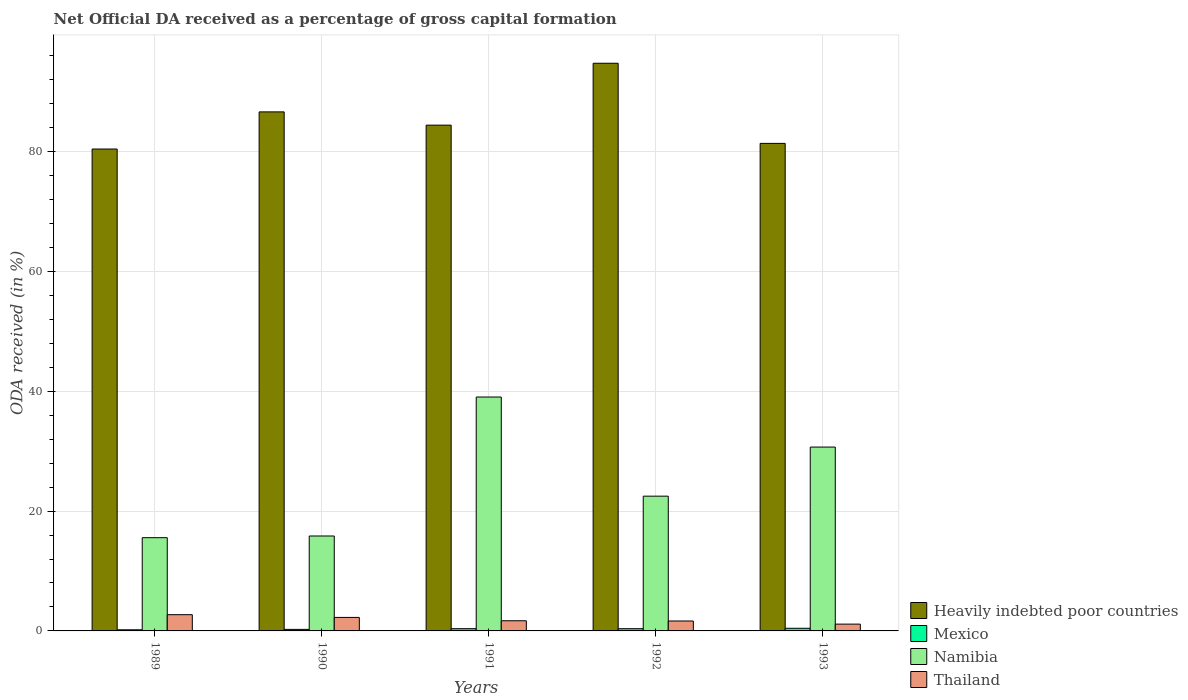How many different coloured bars are there?
Give a very brief answer. 4. How many groups of bars are there?
Provide a short and direct response. 5. Are the number of bars per tick equal to the number of legend labels?
Your answer should be very brief. Yes. Are the number of bars on each tick of the X-axis equal?
Provide a short and direct response. Yes. In how many cases, is the number of bars for a given year not equal to the number of legend labels?
Keep it short and to the point. 0. What is the net ODA received in Heavily indebted poor countries in 1990?
Offer a very short reply. 86.64. Across all years, what is the maximum net ODA received in Heavily indebted poor countries?
Provide a short and direct response. 94.76. Across all years, what is the minimum net ODA received in Mexico?
Provide a short and direct response. 0.19. In which year was the net ODA received in Heavily indebted poor countries maximum?
Keep it short and to the point. 1992. What is the total net ODA received in Namibia in the graph?
Give a very brief answer. 123.64. What is the difference between the net ODA received in Namibia in 1989 and that in 1993?
Make the answer very short. -15.12. What is the difference between the net ODA received in Namibia in 1989 and the net ODA received in Mexico in 1990?
Give a very brief answer. 15.31. What is the average net ODA received in Heavily indebted poor countries per year?
Your response must be concise. 85.53. In the year 1993, what is the difference between the net ODA received in Thailand and net ODA received in Mexico?
Offer a terse response. 0.69. What is the ratio of the net ODA received in Namibia in 1990 to that in 1993?
Offer a terse response. 0.52. Is the net ODA received in Mexico in 1990 less than that in 1992?
Make the answer very short. Yes. What is the difference between the highest and the second highest net ODA received in Thailand?
Keep it short and to the point. 0.46. What is the difference between the highest and the lowest net ODA received in Namibia?
Keep it short and to the point. 23.48. In how many years, is the net ODA received in Mexico greater than the average net ODA received in Mexico taken over all years?
Provide a short and direct response. 3. Is it the case that in every year, the sum of the net ODA received in Namibia and net ODA received in Mexico is greater than the sum of net ODA received in Heavily indebted poor countries and net ODA received in Thailand?
Keep it short and to the point. Yes. What does the 2nd bar from the left in 1990 represents?
Your response must be concise. Mexico. What does the 2nd bar from the right in 1991 represents?
Give a very brief answer. Namibia. Is it the case that in every year, the sum of the net ODA received in Heavily indebted poor countries and net ODA received in Namibia is greater than the net ODA received in Mexico?
Your response must be concise. Yes. How many years are there in the graph?
Your response must be concise. 5. How many legend labels are there?
Offer a very short reply. 4. How are the legend labels stacked?
Your answer should be compact. Vertical. What is the title of the graph?
Your answer should be compact. Net Official DA received as a percentage of gross capital formation. What is the label or title of the Y-axis?
Your response must be concise. ODA received (in %). What is the ODA received (in %) in Heavily indebted poor countries in 1989?
Offer a very short reply. 80.44. What is the ODA received (in %) in Mexico in 1989?
Your response must be concise. 0.19. What is the ODA received (in %) of Namibia in 1989?
Make the answer very short. 15.57. What is the ODA received (in %) in Thailand in 1989?
Your answer should be compact. 2.71. What is the ODA received (in %) of Heavily indebted poor countries in 1990?
Your answer should be very brief. 86.64. What is the ODA received (in %) in Mexico in 1990?
Your response must be concise. 0.26. What is the ODA received (in %) of Namibia in 1990?
Offer a very short reply. 15.85. What is the ODA received (in %) in Thailand in 1990?
Your answer should be compact. 2.25. What is the ODA received (in %) of Heavily indebted poor countries in 1991?
Provide a short and direct response. 84.43. What is the ODA received (in %) of Mexico in 1991?
Your response must be concise. 0.37. What is the ODA received (in %) of Namibia in 1991?
Offer a very short reply. 39.04. What is the ODA received (in %) in Thailand in 1991?
Provide a succinct answer. 1.7. What is the ODA received (in %) of Heavily indebted poor countries in 1992?
Your response must be concise. 94.76. What is the ODA received (in %) in Mexico in 1992?
Give a very brief answer. 0.37. What is the ODA received (in %) in Namibia in 1992?
Make the answer very short. 22.49. What is the ODA received (in %) in Thailand in 1992?
Your response must be concise. 1.66. What is the ODA received (in %) of Heavily indebted poor countries in 1993?
Give a very brief answer. 81.38. What is the ODA received (in %) in Mexico in 1993?
Your answer should be compact. 0.44. What is the ODA received (in %) of Namibia in 1993?
Ensure brevity in your answer.  30.69. What is the ODA received (in %) in Thailand in 1993?
Provide a succinct answer. 1.14. Across all years, what is the maximum ODA received (in %) in Heavily indebted poor countries?
Offer a terse response. 94.76. Across all years, what is the maximum ODA received (in %) of Mexico?
Your response must be concise. 0.44. Across all years, what is the maximum ODA received (in %) of Namibia?
Your answer should be very brief. 39.04. Across all years, what is the maximum ODA received (in %) in Thailand?
Provide a succinct answer. 2.71. Across all years, what is the minimum ODA received (in %) of Heavily indebted poor countries?
Offer a very short reply. 80.44. Across all years, what is the minimum ODA received (in %) in Mexico?
Provide a short and direct response. 0.19. Across all years, what is the minimum ODA received (in %) of Namibia?
Ensure brevity in your answer.  15.57. Across all years, what is the minimum ODA received (in %) in Thailand?
Your answer should be compact. 1.14. What is the total ODA received (in %) of Heavily indebted poor countries in the graph?
Your response must be concise. 427.64. What is the total ODA received (in %) in Mexico in the graph?
Offer a terse response. 1.63. What is the total ODA received (in %) of Namibia in the graph?
Provide a succinct answer. 123.64. What is the total ODA received (in %) in Thailand in the graph?
Your answer should be very brief. 9.45. What is the difference between the ODA received (in %) in Heavily indebted poor countries in 1989 and that in 1990?
Keep it short and to the point. -6.2. What is the difference between the ODA received (in %) of Mexico in 1989 and that in 1990?
Make the answer very short. -0.07. What is the difference between the ODA received (in %) of Namibia in 1989 and that in 1990?
Keep it short and to the point. -0.28. What is the difference between the ODA received (in %) in Thailand in 1989 and that in 1990?
Make the answer very short. 0.46. What is the difference between the ODA received (in %) of Heavily indebted poor countries in 1989 and that in 1991?
Your answer should be compact. -3.99. What is the difference between the ODA received (in %) in Mexico in 1989 and that in 1991?
Provide a short and direct response. -0.18. What is the difference between the ODA received (in %) in Namibia in 1989 and that in 1991?
Provide a short and direct response. -23.48. What is the difference between the ODA received (in %) in Thailand in 1989 and that in 1991?
Your answer should be compact. 1.01. What is the difference between the ODA received (in %) of Heavily indebted poor countries in 1989 and that in 1992?
Give a very brief answer. -14.32. What is the difference between the ODA received (in %) in Mexico in 1989 and that in 1992?
Offer a very short reply. -0.18. What is the difference between the ODA received (in %) of Namibia in 1989 and that in 1992?
Give a very brief answer. -6.93. What is the difference between the ODA received (in %) of Thailand in 1989 and that in 1992?
Ensure brevity in your answer.  1.05. What is the difference between the ODA received (in %) in Heavily indebted poor countries in 1989 and that in 1993?
Provide a short and direct response. -0.94. What is the difference between the ODA received (in %) in Mexico in 1989 and that in 1993?
Your response must be concise. -0.25. What is the difference between the ODA received (in %) of Namibia in 1989 and that in 1993?
Keep it short and to the point. -15.12. What is the difference between the ODA received (in %) of Thailand in 1989 and that in 1993?
Make the answer very short. 1.57. What is the difference between the ODA received (in %) of Heavily indebted poor countries in 1990 and that in 1991?
Your response must be concise. 2.21. What is the difference between the ODA received (in %) in Mexico in 1990 and that in 1991?
Give a very brief answer. -0.12. What is the difference between the ODA received (in %) in Namibia in 1990 and that in 1991?
Make the answer very short. -23.2. What is the difference between the ODA received (in %) in Thailand in 1990 and that in 1991?
Provide a short and direct response. 0.56. What is the difference between the ODA received (in %) of Heavily indebted poor countries in 1990 and that in 1992?
Ensure brevity in your answer.  -8.12. What is the difference between the ODA received (in %) of Mexico in 1990 and that in 1992?
Offer a terse response. -0.11. What is the difference between the ODA received (in %) of Namibia in 1990 and that in 1992?
Provide a succinct answer. -6.65. What is the difference between the ODA received (in %) of Thailand in 1990 and that in 1992?
Offer a terse response. 0.6. What is the difference between the ODA received (in %) of Heavily indebted poor countries in 1990 and that in 1993?
Your answer should be compact. 5.26. What is the difference between the ODA received (in %) in Mexico in 1990 and that in 1993?
Offer a terse response. -0.19. What is the difference between the ODA received (in %) in Namibia in 1990 and that in 1993?
Ensure brevity in your answer.  -14.84. What is the difference between the ODA received (in %) in Thailand in 1990 and that in 1993?
Provide a short and direct response. 1.12. What is the difference between the ODA received (in %) in Heavily indebted poor countries in 1991 and that in 1992?
Your answer should be very brief. -10.33. What is the difference between the ODA received (in %) in Mexico in 1991 and that in 1992?
Your answer should be very brief. 0. What is the difference between the ODA received (in %) of Namibia in 1991 and that in 1992?
Offer a very short reply. 16.55. What is the difference between the ODA received (in %) of Thailand in 1991 and that in 1992?
Ensure brevity in your answer.  0.04. What is the difference between the ODA received (in %) of Heavily indebted poor countries in 1991 and that in 1993?
Provide a short and direct response. 3.05. What is the difference between the ODA received (in %) of Mexico in 1991 and that in 1993?
Your answer should be compact. -0.07. What is the difference between the ODA received (in %) in Namibia in 1991 and that in 1993?
Make the answer very short. 8.35. What is the difference between the ODA received (in %) of Thailand in 1991 and that in 1993?
Provide a succinct answer. 0.56. What is the difference between the ODA received (in %) in Heavily indebted poor countries in 1992 and that in 1993?
Offer a terse response. 13.38. What is the difference between the ODA received (in %) of Mexico in 1992 and that in 1993?
Make the answer very short. -0.07. What is the difference between the ODA received (in %) in Namibia in 1992 and that in 1993?
Your answer should be compact. -8.2. What is the difference between the ODA received (in %) in Thailand in 1992 and that in 1993?
Provide a short and direct response. 0.52. What is the difference between the ODA received (in %) in Heavily indebted poor countries in 1989 and the ODA received (in %) in Mexico in 1990?
Your answer should be very brief. 80.18. What is the difference between the ODA received (in %) of Heavily indebted poor countries in 1989 and the ODA received (in %) of Namibia in 1990?
Your answer should be compact. 64.59. What is the difference between the ODA received (in %) in Heavily indebted poor countries in 1989 and the ODA received (in %) in Thailand in 1990?
Your response must be concise. 78.19. What is the difference between the ODA received (in %) of Mexico in 1989 and the ODA received (in %) of Namibia in 1990?
Your answer should be very brief. -15.66. What is the difference between the ODA received (in %) of Mexico in 1989 and the ODA received (in %) of Thailand in 1990?
Provide a short and direct response. -2.07. What is the difference between the ODA received (in %) in Namibia in 1989 and the ODA received (in %) in Thailand in 1990?
Your response must be concise. 13.31. What is the difference between the ODA received (in %) of Heavily indebted poor countries in 1989 and the ODA received (in %) of Mexico in 1991?
Your answer should be compact. 80.07. What is the difference between the ODA received (in %) of Heavily indebted poor countries in 1989 and the ODA received (in %) of Namibia in 1991?
Your answer should be compact. 41.4. What is the difference between the ODA received (in %) in Heavily indebted poor countries in 1989 and the ODA received (in %) in Thailand in 1991?
Give a very brief answer. 78.74. What is the difference between the ODA received (in %) in Mexico in 1989 and the ODA received (in %) in Namibia in 1991?
Ensure brevity in your answer.  -38.86. What is the difference between the ODA received (in %) of Mexico in 1989 and the ODA received (in %) of Thailand in 1991?
Provide a short and direct response. -1.51. What is the difference between the ODA received (in %) of Namibia in 1989 and the ODA received (in %) of Thailand in 1991?
Offer a very short reply. 13.87. What is the difference between the ODA received (in %) of Heavily indebted poor countries in 1989 and the ODA received (in %) of Mexico in 1992?
Offer a terse response. 80.07. What is the difference between the ODA received (in %) in Heavily indebted poor countries in 1989 and the ODA received (in %) in Namibia in 1992?
Offer a terse response. 57.95. What is the difference between the ODA received (in %) in Heavily indebted poor countries in 1989 and the ODA received (in %) in Thailand in 1992?
Make the answer very short. 78.78. What is the difference between the ODA received (in %) of Mexico in 1989 and the ODA received (in %) of Namibia in 1992?
Make the answer very short. -22.31. What is the difference between the ODA received (in %) in Mexico in 1989 and the ODA received (in %) in Thailand in 1992?
Your answer should be compact. -1.47. What is the difference between the ODA received (in %) in Namibia in 1989 and the ODA received (in %) in Thailand in 1992?
Make the answer very short. 13.91. What is the difference between the ODA received (in %) of Heavily indebted poor countries in 1989 and the ODA received (in %) of Mexico in 1993?
Make the answer very short. 80. What is the difference between the ODA received (in %) of Heavily indebted poor countries in 1989 and the ODA received (in %) of Namibia in 1993?
Provide a short and direct response. 49.75. What is the difference between the ODA received (in %) in Heavily indebted poor countries in 1989 and the ODA received (in %) in Thailand in 1993?
Give a very brief answer. 79.3. What is the difference between the ODA received (in %) in Mexico in 1989 and the ODA received (in %) in Namibia in 1993?
Your response must be concise. -30.5. What is the difference between the ODA received (in %) in Mexico in 1989 and the ODA received (in %) in Thailand in 1993?
Provide a short and direct response. -0.95. What is the difference between the ODA received (in %) of Namibia in 1989 and the ODA received (in %) of Thailand in 1993?
Provide a succinct answer. 14.43. What is the difference between the ODA received (in %) of Heavily indebted poor countries in 1990 and the ODA received (in %) of Mexico in 1991?
Your answer should be very brief. 86.27. What is the difference between the ODA received (in %) in Heavily indebted poor countries in 1990 and the ODA received (in %) in Namibia in 1991?
Offer a terse response. 47.59. What is the difference between the ODA received (in %) of Heavily indebted poor countries in 1990 and the ODA received (in %) of Thailand in 1991?
Make the answer very short. 84.94. What is the difference between the ODA received (in %) in Mexico in 1990 and the ODA received (in %) in Namibia in 1991?
Ensure brevity in your answer.  -38.79. What is the difference between the ODA received (in %) in Mexico in 1990 and the ODA received (in %) in Thailand in 1991?
Your answer should be very brief. -1.44. What is the difference between the ODA received (in %) of Namibia in 1990 and the ODA received (in %) of Thailand in 1991?
Provide a short and direct response. 14.15. What is the difference between the ODA received (in %) of Heavily indebted poor countries in 1990 and the ODA received (in %) of Mexico in 1992?
Offer a very short reply. 86.27. What is the difference between the ODA received (in %) in Heavily indebted poor countries in 1990 and the ODA received (in %) in Namibia in 1992?
Your response must be concise. 64.14. What is the difference between the ODA received (in %) of Heavily indebted poor countries in 1990 and the ODA received (in %) of Thailand in 1992?
Provide a short and direct response. 84.98. What is the difference between the ODA received (in %) of Mexico in 1990 and the ODA received (in %) of Namibia in 1992?
Offer a terse response. -22.24. What is the difference between the ODA received (in %) in Mexico in 1990 and the ODA received (in %) in Thailand in 1992?
Your answer should be very brief. -1.4. What is the difference between the ODA received (in %) of Namibia in 1990 and the ODA received (in %) of Thailand in 1992?
Your response must be concise. 14.19. What is the difference between the ODA received (in %) in Heavily indebted poor countries in 1990 and the ODA received (in %) in Mexico in 1993?
Your answer should be very brief. 86.2. What is the difference between the ODA received (in %) of Heavily indebted poor countries in 1990 and the ODA received (in %) of Namibia in 1993?
Give a very brief answer. 55.95. What is the difference between the ODA received (in %) of Heavily indebted poor countries in 1990 and the ODA received (in %) of Thailand in 1993?
Provide a short and direct response. 85.5. What is the difference between the ODA received (in %) of Mexico in 1990 and the ODA received (in %) of Namibia in 1993?
Offer a terse response. -30.43. What is the difference between the ODA received (in %) of Mexico in 1990 and the ODA received (in %) of Thailand in 1993?
Make the answer very short. -0.88. What is the difference between the ODA received (in %) of Namibia in 1990 and the ODA received (in %) of Thailand in 1993?
Offer a terse response. 14.71. What is the difference between the ODA received (in %) in Heavily indebted poor countries in 1991 and the ODA received (in %) in Mexico in 1992?
Offer a terse response. 84.06. What is the difference between the ODA received (in %) in Heavily indebted poor countries in 1991 and the ODA received (in %) in Namibia in 1992?
Provide a short and direct response. 61.93. What is the difference between the ODA received (in %) in Heavily indebted poor countries in 1991 and the ODA received (in %) in Thailand in 1992?
Offer a terse response. 82.77. What is the difference between the ODA received (in %) in Mexico in 1991 and the ODA received (in %) in Namibia in 1992?
Provide a short and direct response. -22.12. What is the difference between the ODA received (in %) of Mexico in 1991 and the ODA received (in %) of Thailand in 1992?
Make the answer very short. -1.28. What is the difference between the ODA received (in %) in Namibia in 1991 and the ODA received (in %) in Thailand in 1992?
Provide a short and direct response. 37.39. What is the difference between the ODA received (in %) in Heavily indebted poor countries in 1991 and the ODA received (in %) in Mexico in 1993?
Make the answer very short. 83.98. What is the difference between the ODA received (in %) of Heavily indebted poor countries in 1991 and the ODA received (in %) of Namibia in 1993?
Provide a succinct answer. 53.74. What is the difference between the ODA received (in %) in Heavily indebted poor countries in 1991 and the ODA received (in %) in Thailand in 1993?
Offer a terse response. 83.29. What is the difference between the ODA received (in %) of Mexico in 1991 and the ODA received (in %) of Namibia in 1993?
Provide a short and direct response. -30.32. What is the difference between the ODA received (in %) of Mexico in 1991 and the ODA received (in %) of Thailand in 1993?
Your answer should be compact. -0.76. What is the difference between the ODA received (in %) in Namibia in 1991 and the ODA received (in %) in Thailand in 1993?
Provide a short and direct response. 37.91. What is the difference between the ODA received (in %) in Heavily indebted poor countries in 1992 and the ODA received (in %) in Mexico in 1993?
Offer a terse response. 94.31. What is the difference between the ODA received (in %) of Heavily indebted poor countries in 1992 and the ODA received (in %) of Namibia in 1993?
Your answer should be very brief. 64.07. What is the difference between the ODA received (in %) of Heavily indebted poor countries in 1992 and the ODA received (in %) of Thailand in 1993?
Offer a very short reply. 93.62. What is the difference between the ODA received (in %) of Mexico in 1992 and the ODA received (in %) of Namibia in 1993?
Your answer should be very brief. -30.32. What is the difference between the ODA received (in %) of Mexico in 1992 and the ODA received (in %) of Thailand in 1993?
Offer a terse response. -0.77. What is the difference between the ODA received (in %) of Namibia in 1992 and the ODA received (in %) of Thailand in 1993?
Offer a very short reply. 21.36. What is the average ODA received (in %) of Heavily indebted poor countries per year?
Give a very brief answer. 85.53. What is the average ODA received (in %) of Mexico per year?
Provide a succinct answer. 0.33. What is the average ODA received (in %) in Namibia per year?
Make the answer very short. 24.73. What is the average ODA received (in %) in Thailand per year?
Offer a terse response. 1.89. In the year 1989, what is the difference between the ODA received (in %) in Heavily indebted poor countries and ODA received (in %) in Mexico?
Give a very brief answer. 80.25. In the year 1989, what is the difference between the ODA received (in %) of Heavily indebted poor countries and ODA received (in %) of Namibia?
Offer a terse response. 64.87. In the year 1989, what is the difference between the ODA received (in %) in Heavily indebted poor countries and ODA received (in %) in Thailand?
Your answer should be compact. 77.73. In the year 1989, what is the difference between the ODA received (in %) of Mexico and ODA received (in %) of Namibia?
Your answer should be very brief. -15.38. In the year 1989, what is the difference between the ODA received (in %) in Mexico and ODA received (in %) in Thailand?
Make the answer very short. -2.52. In the year 1989, what is the difference between the ODA received (in %) of Namibia and ODA received (in %) of Thailand?
Offer a terse response. 12.85. In the year 1990, what is the difference between the ODA received (in %) of Heavily indebted poor countries and ODA received (in %) of Mexico?
Keep it short and to the point. 86.38. In the year 1990, what is the difference between the ODA received (in %) in Heavily indebted poor countries and ODA received (in %) in Namibia?
Offer a terse response. 70.79. In the year 1990, what is the difference between the ODA received (in %) of Heavily indebted poor countries and ODA received (in %) of Thailand?
Ensure brevity in your answer.  84.39. In the year 1990, what is the difference between the ODA received (in %) in Mexico and ODA received (in %) in Namibia?
Offer a very short reply. -15.59. In the year 1990, what is the difference between the ODA received (in %) in Mexico and ODA received (in %) in Thailand?
Your response must be concise. -2. In the year 1990, what is the difference between the ODA received (in %) in Namibia and ODA received (in %) in Thailand?
Give a very brief answer. 13.59. In the year 1991, what is the difference between the ODA received (in %) of Heavily indebted poor countries and ODA received (in %) of Mexico?
Ensure brevity in your answer.  84.05. In the year 1991, what is the difference between the ODA received (in %) of Heavily indebted poor countries and ODA received (in %) of Namibia?
Provide a succinct answer. 45.38. In the year 1991, what is the difference between the ODA received (in %) in Heavily indebted poor countries and ODA received (in %) in Thailand?
Your answer should be compact. 82.73. In the year 1991, what is the difference between the ODA received (in %) in Mexico and ODA received (in %) in Namibia?
Your response must be concise. -38.67. In the year 1991, what is the difference between the ODA received (in %) in Mexico and ODA received (in %) in Thailand?
Provide a short and direct response. -1.32. In the year 1991, what is the difference between the ODA received (in %) of Namibia and ODA received (in %) of Thailand?
Your response must be concise. 37.35. In the year 1992, what is the difference between the ODA received (in %) of Heavily indebted poor countries and ODA received (in %) of Mexico?
Ensure brevity in your answer.  94.39. In the year 1992, what is the difference between the ODA received (in %) in Heavily indebted poor countries and ODA received (in %) in Namibia?
Give a very brief answer. 72.26. In the year 1992, what is the difference between the ODA received (in %) of Heavily indebted poor countries and ODA received (in %) of Thailand?
Make the answer very short. 93.1. In the year 1992, what is the difference between the ODA received (in %) in Mexico and ODA received (in %) in Namibia?
Provide a succinct answer. -22.12. In the year 1992, what is the difference between the ODA received (in %) of Mexico and ODA received (in %) of Thailand?
Ensure brevity in your answer.  -1.29. In the year 1992, what is the difference between the ODA received (in %) of Namibia and ODA received (in %) of Thailand?
Make the answer very short. 20.84. In the year 1993, what is the difference between the ODA received (in %) of Heavily indebted poor countries and ODA received (in %) of Mexico?
Offer a very short reply. 80.94. In the year 1993, what is the difference between the ODA received (in %) in Heavily indebted poor countries and ODA received (in %) in Namibia?
Ensure brevity in your answer.  50.69. In the year 1993, what is the difference between the ODA received (in %) of Heavily indebted poor countries and ODA received (in %) of Thailand?
Give a very brief answer. 80.25. In the year 1993, what is the difference between the ODA received (in %) in Mexico and ODA received (in %) in Namibia?
Keep it short and to the point. -30.25. In the year 1993, what is the difference between the ODA received (in %) in Mexico and ODA received (in %) in Thailand?
Provide a succinct answer. -0.69. In the year 1993, what is the difference between the ODA received (in %) in Namibia and ODA received (in %) in Thailand?
Ensure brevity in your answer.  29.55. What is the ratio of the ODA received (in %) in Heavily indebted poor countries in 1989 to that in 1990?
Ensure brevity in your answer.  0.93. What is the ratio of the ODA received (in %) of Mexico in 1989 to that in 1990?
Provide a short and direct response. 0.73. What is the ratio of the ODA received (in %) in Namibia in 1989 to that in 1990?
Make the answer very short. 0.98. What is the ratio of the ODA received (in %) of Thailand in 1989 to that in 1990?
Provide a short and direct response. 1.2. What is the ratio of the ODA received (in %) in Heavily indebted poor countries in 1989 to that in 1991?
Offer a terse response. 0.95. What is the ratio of the ODA received (in %) of Mexico in 1989 to that in 1991?
Give a very brief answer. 0.51. What is the ratio of the ODA received (in %) of Namibia in 1989 to that in 1991?
Your answer should be very brief. 0.4. What is the ratio of the ODA received (in %) in Thailand in 1989 to that in 1991?
Offer a very short reply. 1.6. What is the ratio of the ODA received (in %) of Heavily indebted poor countries in 1989 to that in 1992?
Your answer should be compact. 0.85. What is the ratio of the ODA received (in %) in Mexico in 1989 to that in 1992?
Offer a terse response. 0.51. What is the ratio of the ODA received (in %) in Namibia in 1989 to that in 1992?
Make the answer very short. 0.69. What is the ratio of the ODA received (in %) in Thailand in 1989 to that in 1992?
Your answer should be compact. 1.64. What is the ratio of the ODA received (in %) in Heavily indebted poor countries in 1989 to that in 1993?
Your answer should be very brief. 0.99. What is the ratio of the ODA received (in %) in Mexico in 1989 to that in 1993?
Provide a succinct answer. 0.43. What is the ratio of the ODA received (in %) in Namibia in 1989 to that in 1993?
Your answer should be compact. 0.51. What is the ratio of the ODA received (in %) in Thailand in 1989 to that in 1993?
Offer a very short reply. 2.39. What is the ratio of the ODA received (in %) of Heavily indebted poor countries in 1990 to that in 1991?
Your answer should be very brief. 1.03. What is the ratio of the ODA received (in %) of Mexico in 1990 to that in 1991?
Your answer should be very brief. 0.69. What is the ratio of the ODA received (in %) of Namibia in 1990 to that in 1991?
Give a very brief answer. 0.41. What is the ratio of the ODA received (in %) of Thailand in 1990 to that in 1991?
Provide a succinct answer. 1.33. What is the ratio of the ODA received (in %) in Heavily indebted poor countries in 1990 to that in 1992?
Ensure brevity in your answer.  0.91. What is the ratio of the ODA received (in %) in Mexico in 1990 to that in 1992?
Ensure brevity in your answer.  0.69. What is the ratio of the ODA received (in %) in Namibia in 1990 to that in 1992?
Your answer should be very brief. 0.7. What is the ratio of the ODA received (in %) in Thailand in 1990 to that in 1992?
Give a very brief answer. 1.36. What is the ratio of the ODA received (in %) in Heavily indebted poor countries in 1990 to that in 1993?
Provide a succinct answer. 1.06. What is the ratio of the ODA received (in %) in Mexico in 1990 to that in 1993?
Your answer should be compact. 0.58. What is the ratio of the ODA received (in %) of Namibia in 1990 to that in 1993?
Ensure brevity in your answer.  0.52. What is the ratio of the ODA received (in %) of Thailand in 1990 to that in 1993?
Your answer should be compact. 1.98. What is the ratio of the ODA received (in %) of Heavily indebted poor countries in 1991 to that in 1992?
Your response must be concise. 0.89. What is the ratio of the ODA received (in %) in Mexico in 1991 to that in 1992?
Provide a succinct answer. 1.01. What is the ratio of the ODA received (in %) in Namibia in 1991 to that in 1992?
Keep it short and to the point. 1.74. What is the ratio of the ODA received (in %) in Thailand in 1991 to that in 1992?
Provide a short and direct response. 1.02. What is the ratio of the ODA received (in %) of Heavily indebted poor countries in 1991 to that in 1993?
Make the answer very short. 1.04. What is the ratio of the ODA received (in %) of Mexico in 1991 to that in 1993?
Make the answer very short. 0.85. What is the ratio of the ODA received (in %) of Namibia in 1991 to that in 1993?
Make the answer very short. 1.27. What is the ratio of the ODA received (in %) of Thailand in 1991 to that in 1993?
Make the answer very short. 1.49. What is the ratio of the ODA received (in %) of Heavily indebted poor countries in 1992 to that in 1993?
Ensure brevity in your answer.  1.16. What is the ratio of the ODA received (in %) of Mexico in 1992 to that in 1993?
Provide a short and direct response. 0.84. What is the ratio of the ODA received (in %) in Namibia in 1992 to that in 1993?
Your response must be concise. 0.73. What is the ratio of the ODA received (in %) of Thailand in 1992 to that in 1993?
Keep it short and to the point. 1.46. What is the difference between the highest and the second highest ODA received (in %) of Heavily indebted poor countries?
Your answer should be compact. 8.12. What is the difference between the highest and the second highest ODA received (in %) of Mexico?
Make the answer very short. 0.07. What is the difference between the highest and the second highest ODA received (in %) in Namibia?
Give a very brief answer. 8.35. What is the difference between the highest and the second highest ODA received (in %) in Thailand?
Offer a terse response. 0.46. What is the difference between the highest and the lowest ODA received (in %) in Heavily indebted poor countries?
Ensure brevity in your answer.  14.32. What is the difference between the highest and the lowest ODA received (in %) in Mexico?
Offer a very short reply. 0.25. What is the difference between the highest and the lowest ODA received (in %) in Namibia?
Make the answer very short. 23.48. What is the difference between the highest and the lowest ODA received (in %) of Thailand?
Your response must be concise. 1.57. 